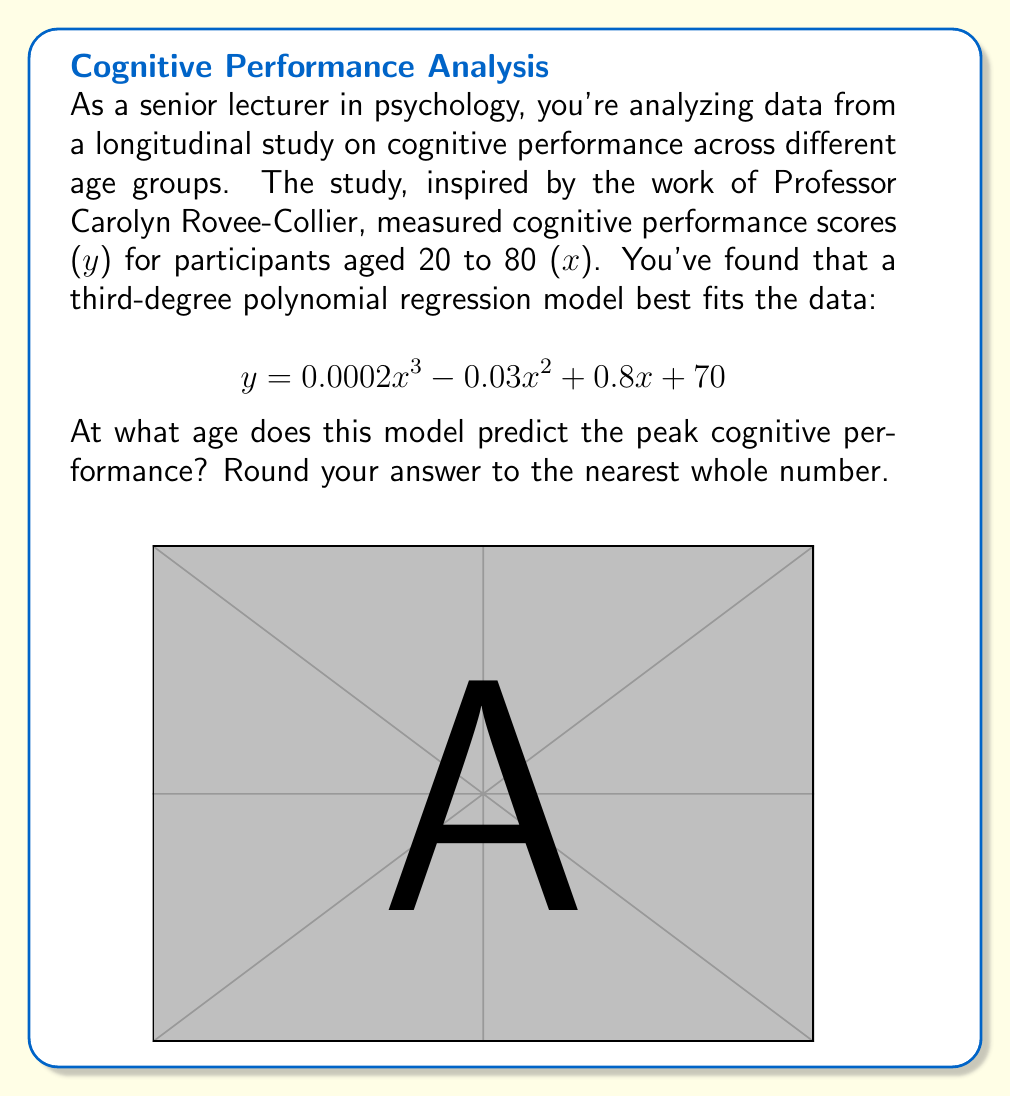Can you solve this math problem? To find the age at which cognitive performance peaks, we need to find the maximum of the given function. This occurs where the derivative of the function equals zero.

Step 1: Find the derivative of the function.
$$\frac{dy}{dx} = 0.0006x^2 - 0.06x + 0.8$$

Step 2: Set the derivative equal to zero and solve for x.
$$0.0006x^2 - 0.06x + 0.8 = 0$$

Step 3: This is a quadratic equation. We can solve it using the quadratic formula:
$$x = \frac{-b \pm \sqrt{b^2 - 4ac}}{2a}$$

Where $a = 0.0006$, $b = -0.06$, and $c = 0.8$

Step 4: Plug these values into the quadratic formula:
$$x = \frac{0.06 \pm \sqrt{(-0.06)^2 - 4(0.0006)(0.8)}}{2(0.0006)}$$

Step 5: Simplify:
$$x = \frac{0.06 \pm \sqrt{0.0036 - 0.00192}}{0.0012} = \frac{0.06 \pm \sqrt{0.00168}}{0.0012} = \frac{0.06 \pm 0.041}{0.0012}$$

Step 6: This gives us two solutions:
$$x_1 = \frac{0.06 + 0.041}{0.0012} \approx 84.17$$
$$x_2 = \frac{0.06 - 0.041}{0.0012} \approx 15.83$$

Step 7: Since we're looking at ages 20 to 80, the relevant solution is 84.17.

Step 8: Rounding to the nearest whole number, we get 84.
Answer: 84 years 